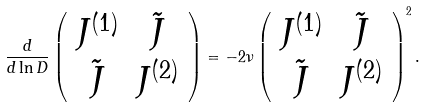<formula> <loc_0><loc_0><loc_500><loc_500>\frac { d } { d \ln D } \left ( \begin{array} { c c } J ^ { ( 1 ) } & \tilde { J } \\ \tilde { J } & J ^ { ( 2 ) } \end{array} \right ) = - 2 \nu \left ( \begin{array} { c c } J ^ { ( 1 ) } & \tilde { J } \\ \tilde { J } & J ^ { ( 2 ) } \end{array} \right ) ^ { 2 } .</formula> 